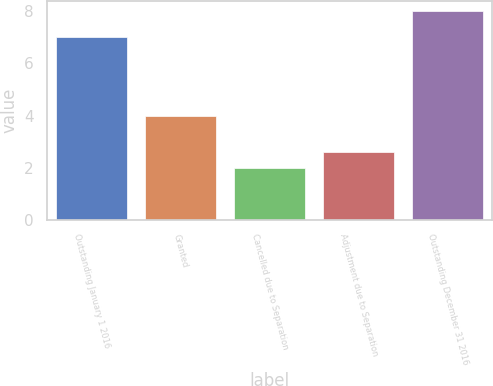<chart> <loc_0><loc_0><loc_500><loc_500><bar_chart><fcel>Outstanding January 1 2016<fcel>Granted<fcel>Cancelled due to Separation<fcel>Adjustment due to Separation<fcel>Outstanding December 31 2016<nl><fcel>7<fcel>4<fcel>2<fcel>2.6<fcel>8<nl></chart> 